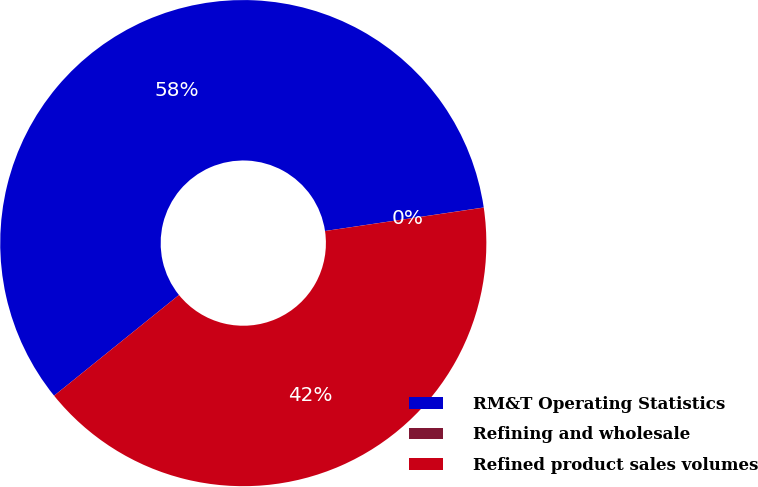Convert chart. <chart><loc_0><loc_0><loc_500><loc_500><pie_chart><fcel>RM&T Operating Statistics<fcel>Refining and wholesale<fcel>Refined product sales volumes<nl><fcel>58.46%<fcel>0.01%<fcel>41.53%<nl></chart> 